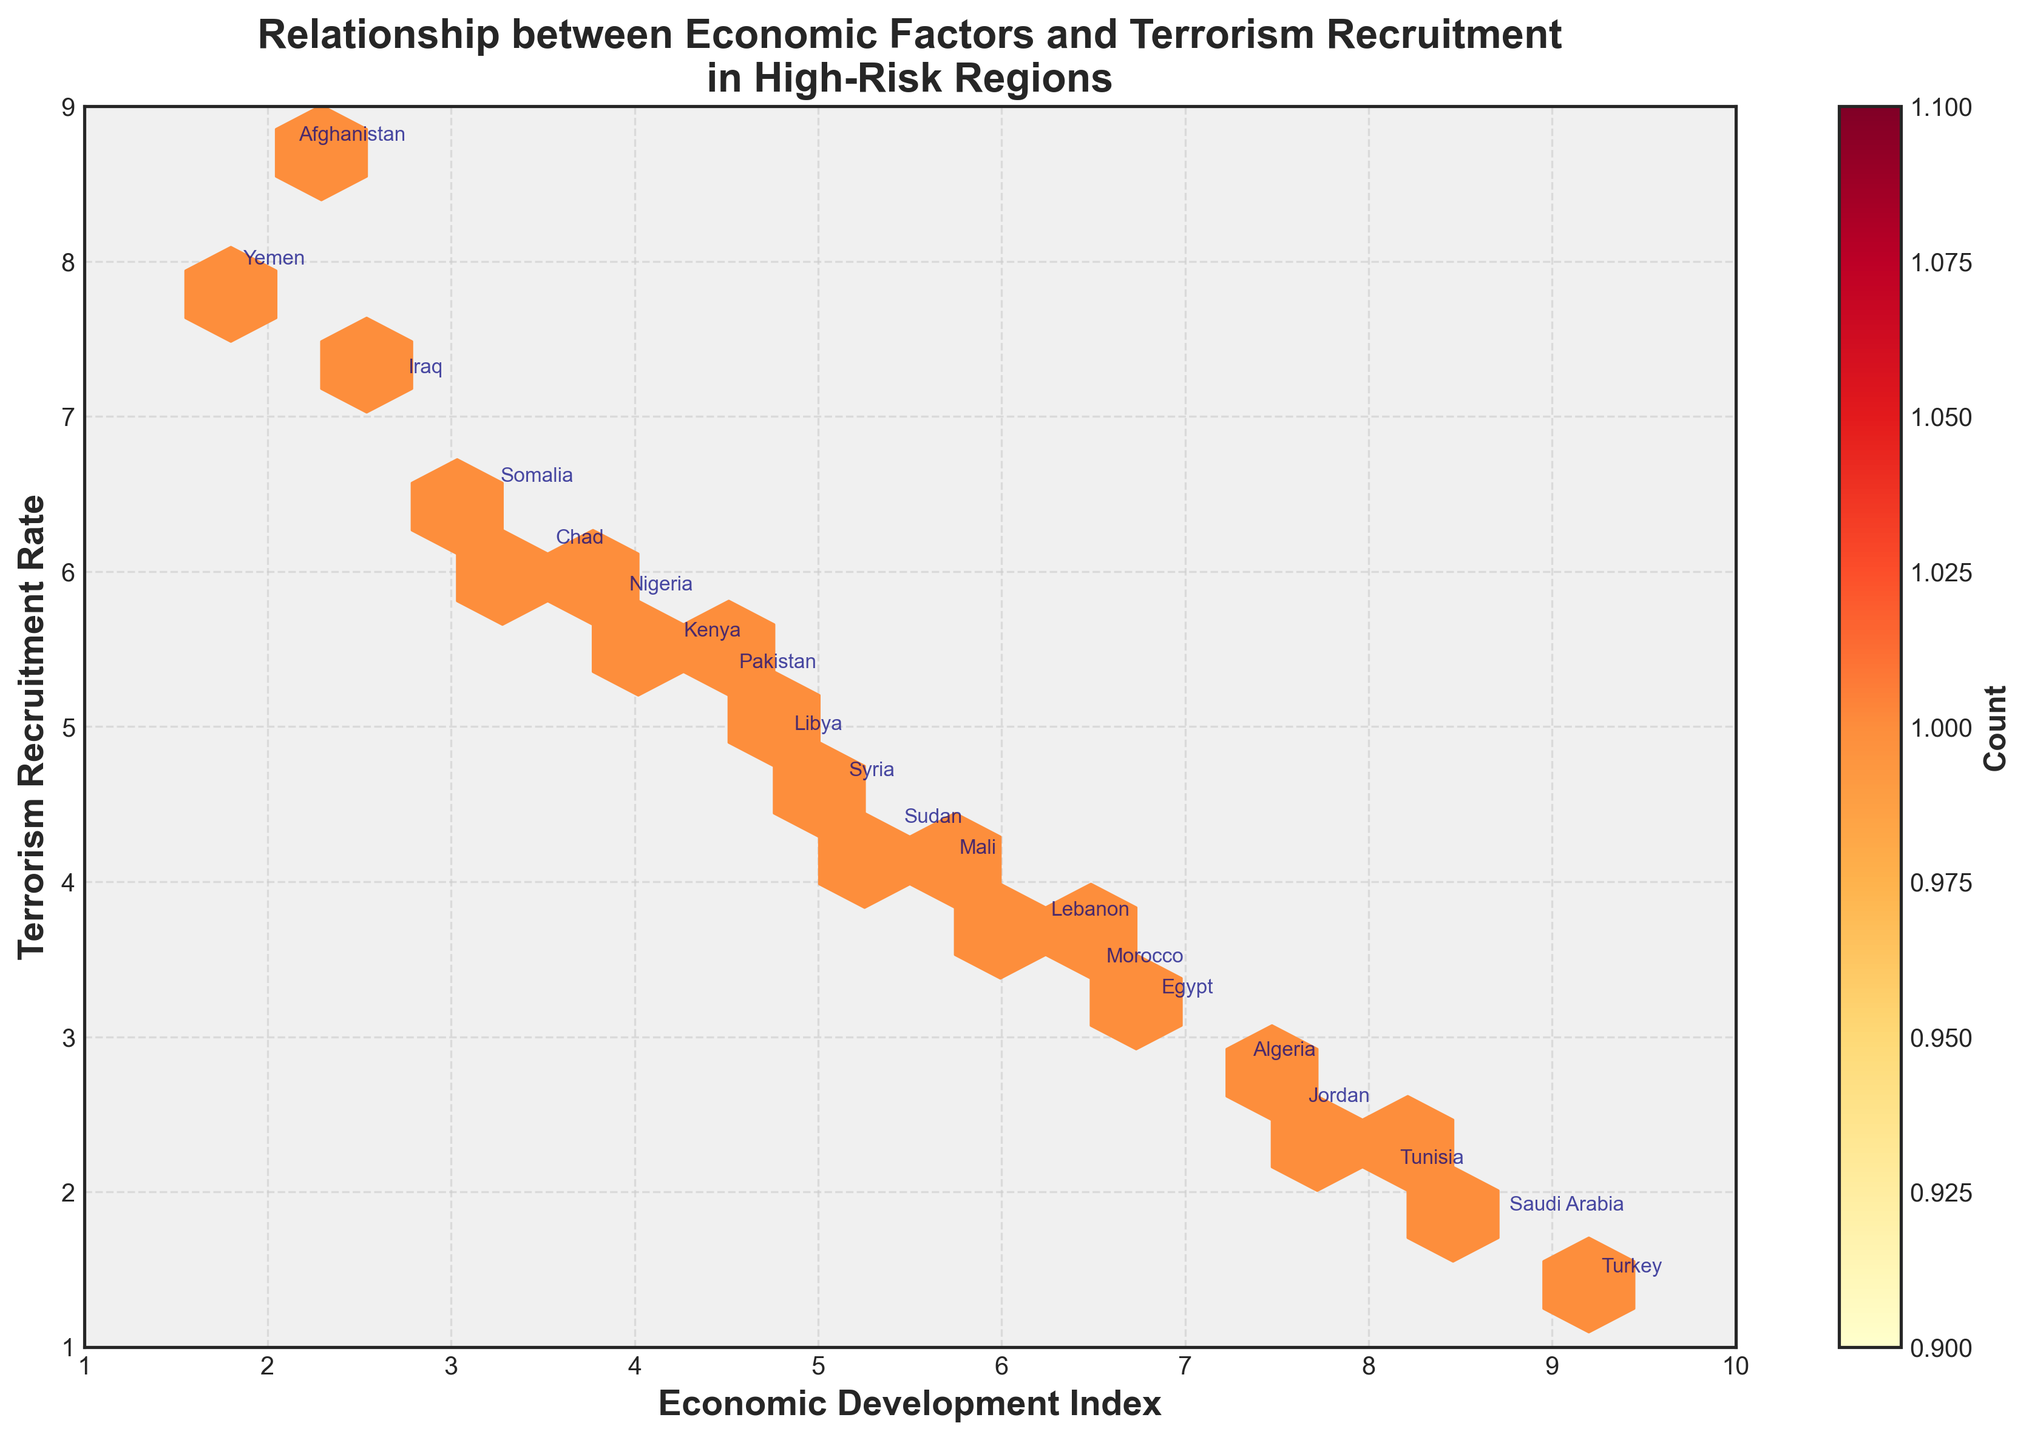What is the title of the plot? The title is placed at the top of the plot and reads "Relationship between Economic Factors and Terrorism Recruitment in High-Risk Regions".
Answer: Relationship between Economic Factors and Terrorism Recruitment in High-Risk Regions What are the x-axis and y-axis labels in the plot? The x-axis is labeled "Economic Development Index" and the y-axis is labeled "Terrorism Recruitment Rate". This is clearly noted along the respective axes.
Answer: Economic Development Index; Terrorism Recruitment Rate How does the color intensity relate to the data in the plot? The color intensity in the hexbin plot represents the count of data points that fall within each hexagonal bin. This information can be inferred from the color bar labeled 'Count' on the right side of the plot.
Answer: Higher intensity indicates more data points Which region has the highest Terrorism Recruitment Rate? By observing the y-axis of the plot, the region with the highest Terrorism Recruitment Rate (8.7) is Afghanistan.
Answer: Afghanistan Which region has the highest Economic Development Index? By looking at the x-axis, the region with the highest Economic Development Index (9.2) is Turkey.
Answer: Turkey How many regions have a Terrorism Recruitment Rate between 4.0 and 6.0? By examining the spread of points along the y-axis between 4.0 and 6.0 and counting the regions, there are six regions: Sudan, Nigeria, Libya, Kenya, Pakistan, and Sudan.
Answer: 6 Which two regions are closest to each other in terms of both indices? By visually comparing the positions of each region on the plot, Libya (4.8, 4.9) and Pakistan (4.5, 5.3) are closest to each other in both Economic Development Index and Terrorism Recruitment Rate.
Answer: Libya and Pakistan Is there a visible trend between Economic Development Index and Terrorism Recruitment Rate? By visually analyzing the plot, a trend can be observed where regions with a higher Economic Development Index tend to have lower Terrorism Recruitment Rates, and vice versa.
Answer: Negative correlation Which region has a higher Terrorism Recruitment Rate: Yemen or Chad? By comparing the y-values of Yemen (7.9) and Chad (6.1) on the plot, Yemen has a higher Terrorism Recruitment Rate.
Answer: Yemen 